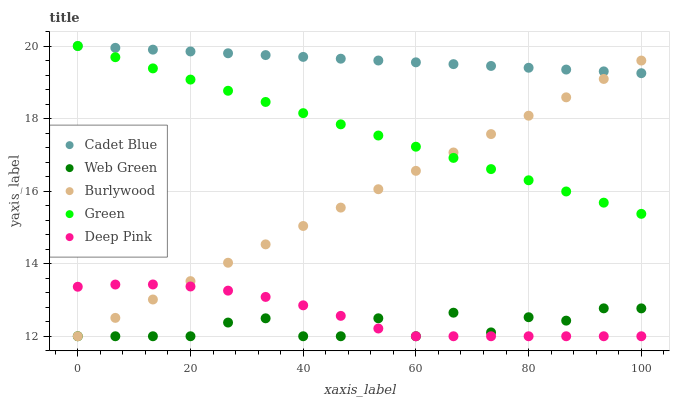Does Web Green have the minimum area under the curve?
Answer yes or no. Yes. Does Cadet Blue have the maximum area under the curve?
Answer yes or no. Yes. Does Green have the minimum area under the curve?
Answer yes or no. No. Does Green have the maximum area under the curve?
Answer yes or no. No. Is Cadet Blue the smoothest?
Answer yes or no. Yes. Is Web Green the roughest?
Answer yes or no. Yes. Is Green the smoothest?
Answer yes or no. No. Is Green the roughest?
Answer yes or no. No. Does Burlywood have the lowest value?
Answer yes or no. Yes. Does Green have the lowest value?
Answer yes or no. No. Does Green have the highest value?
Answer yes or no. Yes. Does Web Green have the highest value?
Answer yes or no. No. Is Deep Pink less than Green?
Answer yes or no. Yes. Is Cadet Blue greater than Deep Pink?
Answer yes or no. Yes. Does Burlywood intersect Deep Pink?
Answer yes or no. Yes. Is Burlywood less than Deep Pink?
Answer yes or no. No. Is Burlywood greater than Deep Pink?
Answer yes or no. No. Does Deep Pink intersect Green?
Answer yes or no. No. 